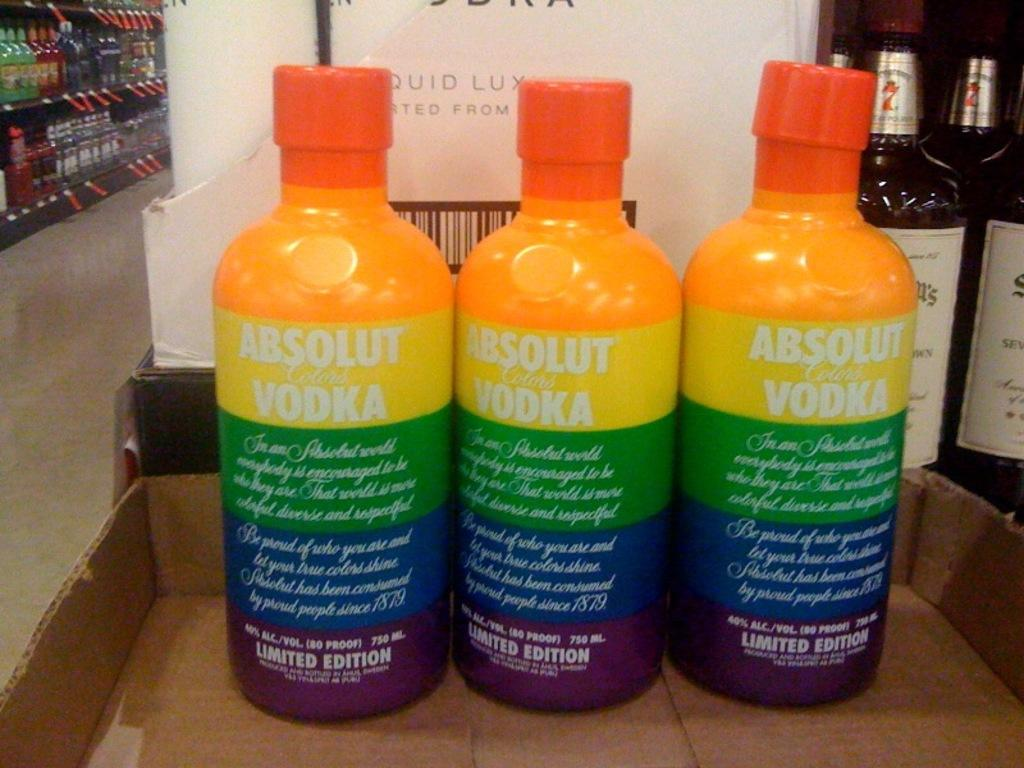Provide a one-sentence caption for the provided image. Three bottles of Absolut Vodka have rainbow colored patterns. 